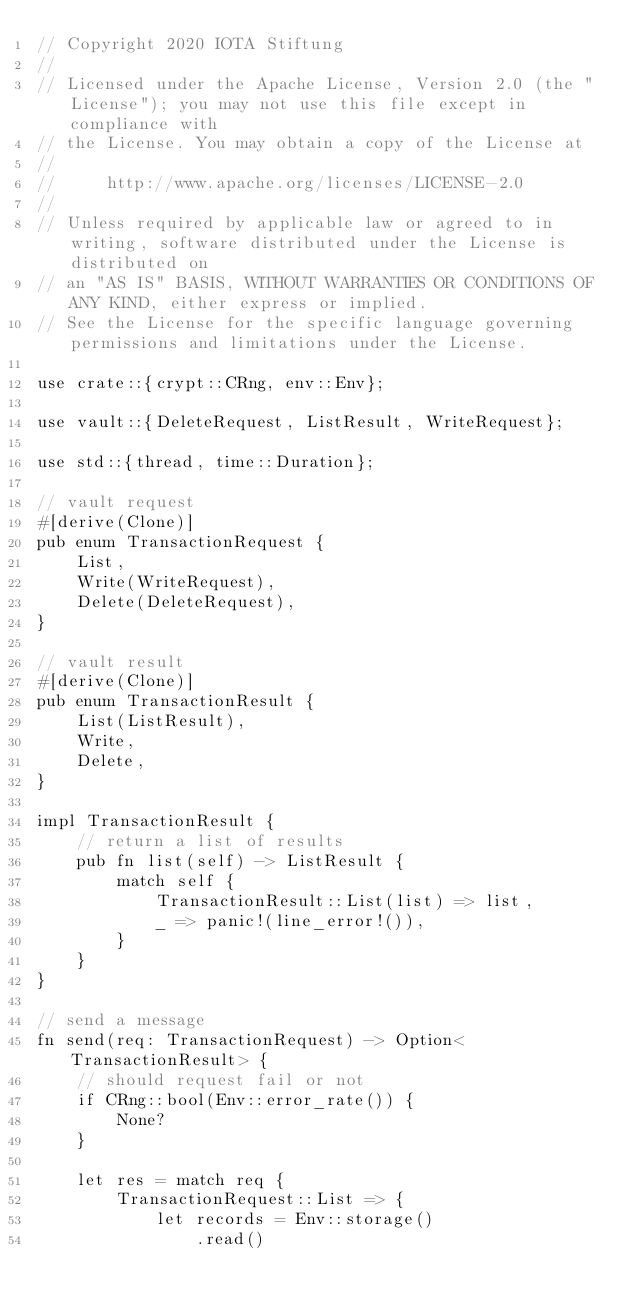Convert code to text. <code><loc_0><loc_0><loc_500><loc_500><_Rust_>// Copyright 2020 IOTA Stiftung
//
// Licensed under the Apache License, Version 2.0 (the "License"); you may not use this file except in compliance with
// the License. You may obtain a copy of the License at
//
//     http://www.apache.org/licenses/LICENSE-2.0
//
// Unless required by applicable law or agreed to in writing, software distributed under the License is distributed on
// an "AS IS" BASIS, WITHOUT WARRANTIES OR CONDITIONS OF ANY KIND, either express or implied.
// See the License for the specific language governing permissions and limitations under the License.

use crate::{crypt::CRng, env::Env};

use vault::{DeleteRequest, ListResult, WriteRequest};

use std::{thread, time::Duration};

// vault request
#[derive(Clone)]
pub enum TransactionRequest {
    List,
    Write(WriteRequest),
    Delete(DeleteRequest),
}

// vault result
#[derive(Clone)]
pub enum TransactionResult {
    List(ListResult),
    Write,
    Delete,
}

impl TransactionResult {
    // return a list of results
    pub fn list(self) -> ListResult {
        match self {
            TransactionResult::List(list) => list,
            _ => panic!(line_error!()),
        }
    }
}

// send a message
fn send(req: TransactionRequest) -> Option<TransactionResult> {
    // should request fail or not
    if CRng::bool(Env::error_rate()) {
        None?
    }

    let res = match req {
        TransactionRequest::List => {
            let records = Env::storage()
                .read()</code> 